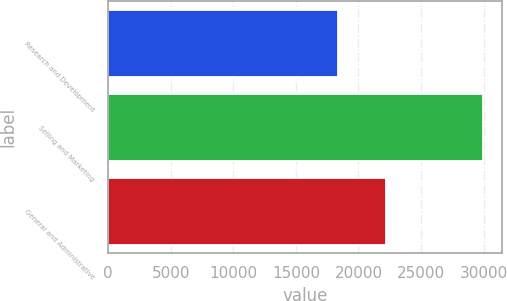Convert chart. <chart><loc_0><loc_0><loc_500><loc_500><bar_chart><fcel>Research and Development<fcel>Selling and Marketing<fcel>General and Administrative<nl><fcel>18381<fcel>29978<fcel>22196<nl></chart> 